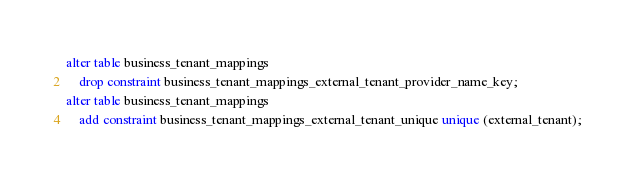Convert code to text. <code><loc_0><loc_0><loc_500><loc_500><_SQL_>alter table business_tenant_mappings
    drop constraint business_tenant_mappings_external_tenant_provider_name_key;
alter table business_tenant_mappings
    add constraint business_tenant_mappings_external_tenant_unique unique (external_tenant);</code> 